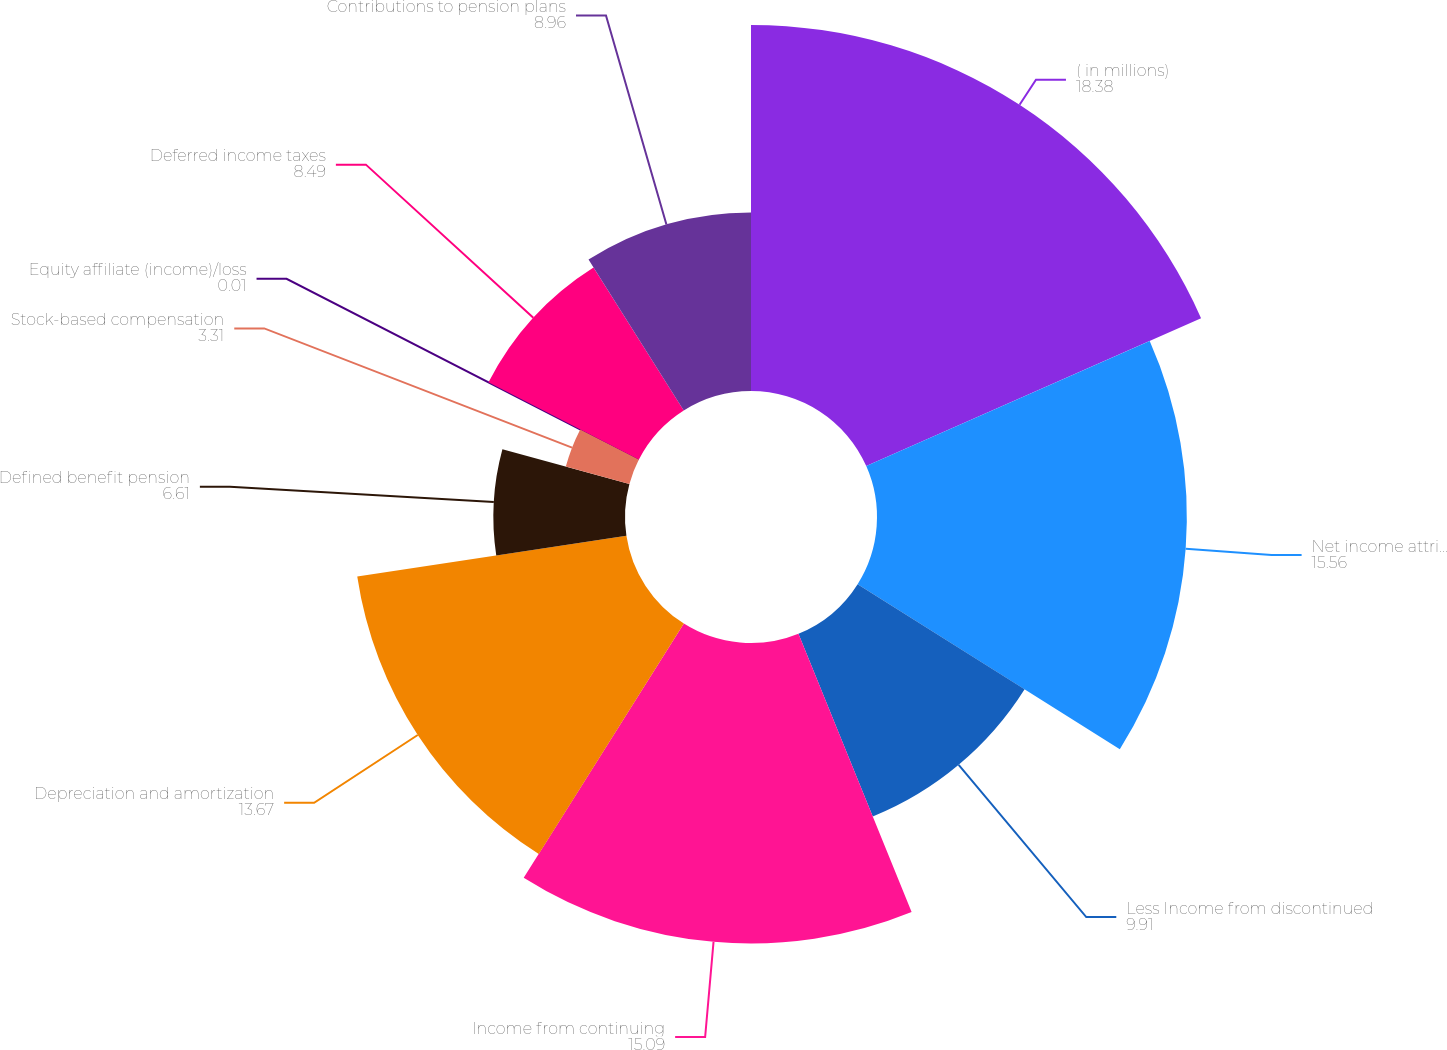Convert chart to OTSL. <chart><loc_0><loc_0><loc_500><loc_500><pie_chart><fcel>( in millions)<fcel>Net income attributable to the<fcel>Less Income from discontinued<fcel>Income from continuing<fcel>Depreciation and amortization<fcel>Defined benefit pension<fcel>Stock-based compensation<fcel>Equity affiliate (income)/loss<fcel>Deferred income taxes<fcel>Contributions to pension plans<nl><fcel>18.38%<fcel>15.56%<fcel>9.91%<fcel>15.09%<fcel>13.67%<fcel>6.61%<fcel>3.31%<fcel>0.01%<fcel>8.49%<fcel>8.96%<nl></chart> 